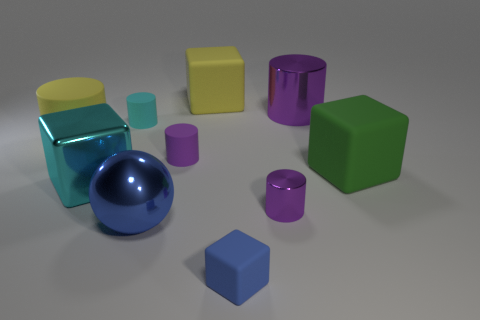Subtract all cyan cubes. How many purple cylinders are left? 3 Subtract all large purple cylinders. How many cylinders are left? 4 Subtract all cyan cylinders. How many cylinders are left? 4 Subtract all gray cylinders. Subtract all purple cubes. How many cylinders are left? 5 Subtract all blocks. How many objects are left? 6 Add 8 metal cubes. How many metal cubes are left? 9 Add 2 large yellow matte objects. How many large yellow matte objects exist? 4 Subtract 0 cyan spheres. How many objects are left? 10 Subtract all big green balls. Subtract all small things. How many objects are left? 6 